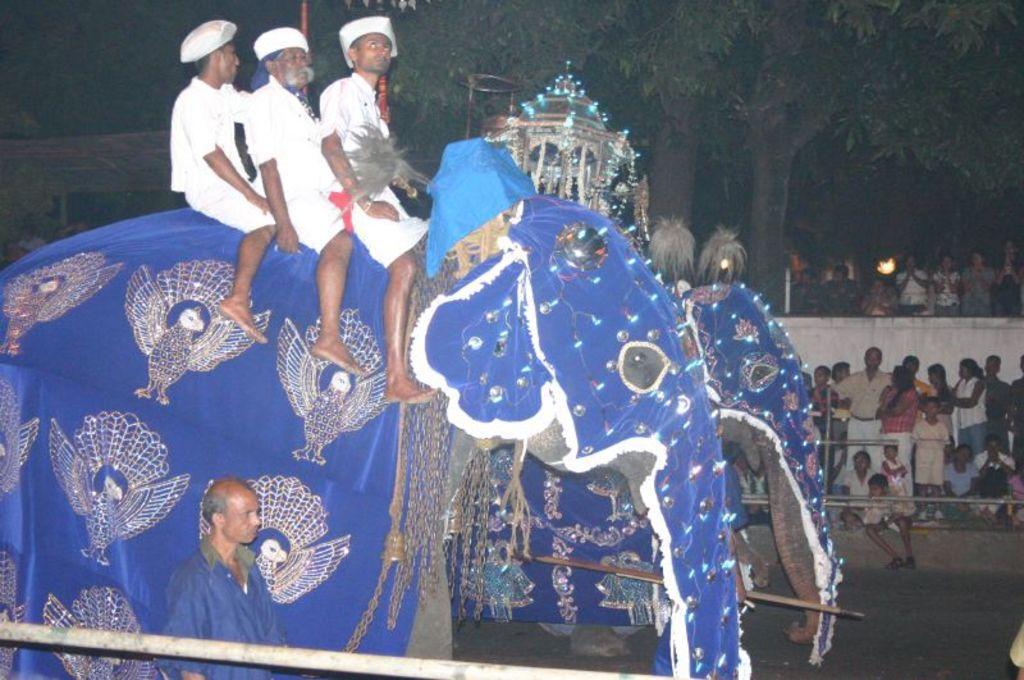Can you describe this image briefly? In this image i can see three man sitting on an elephant at the right there are few other persons standing at the back ground i can see a tree and some persons. 